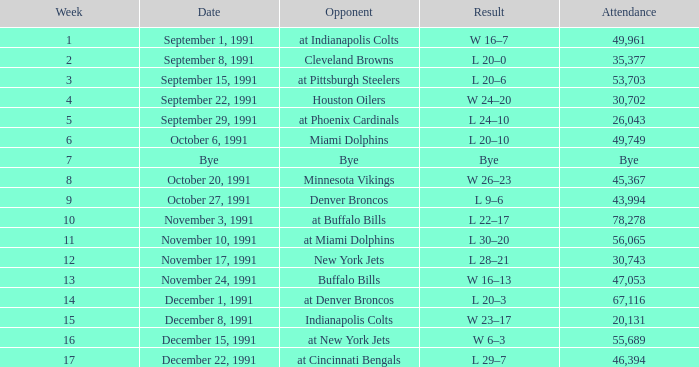Who did the Patriots play in week 4? Houston Oilers. 